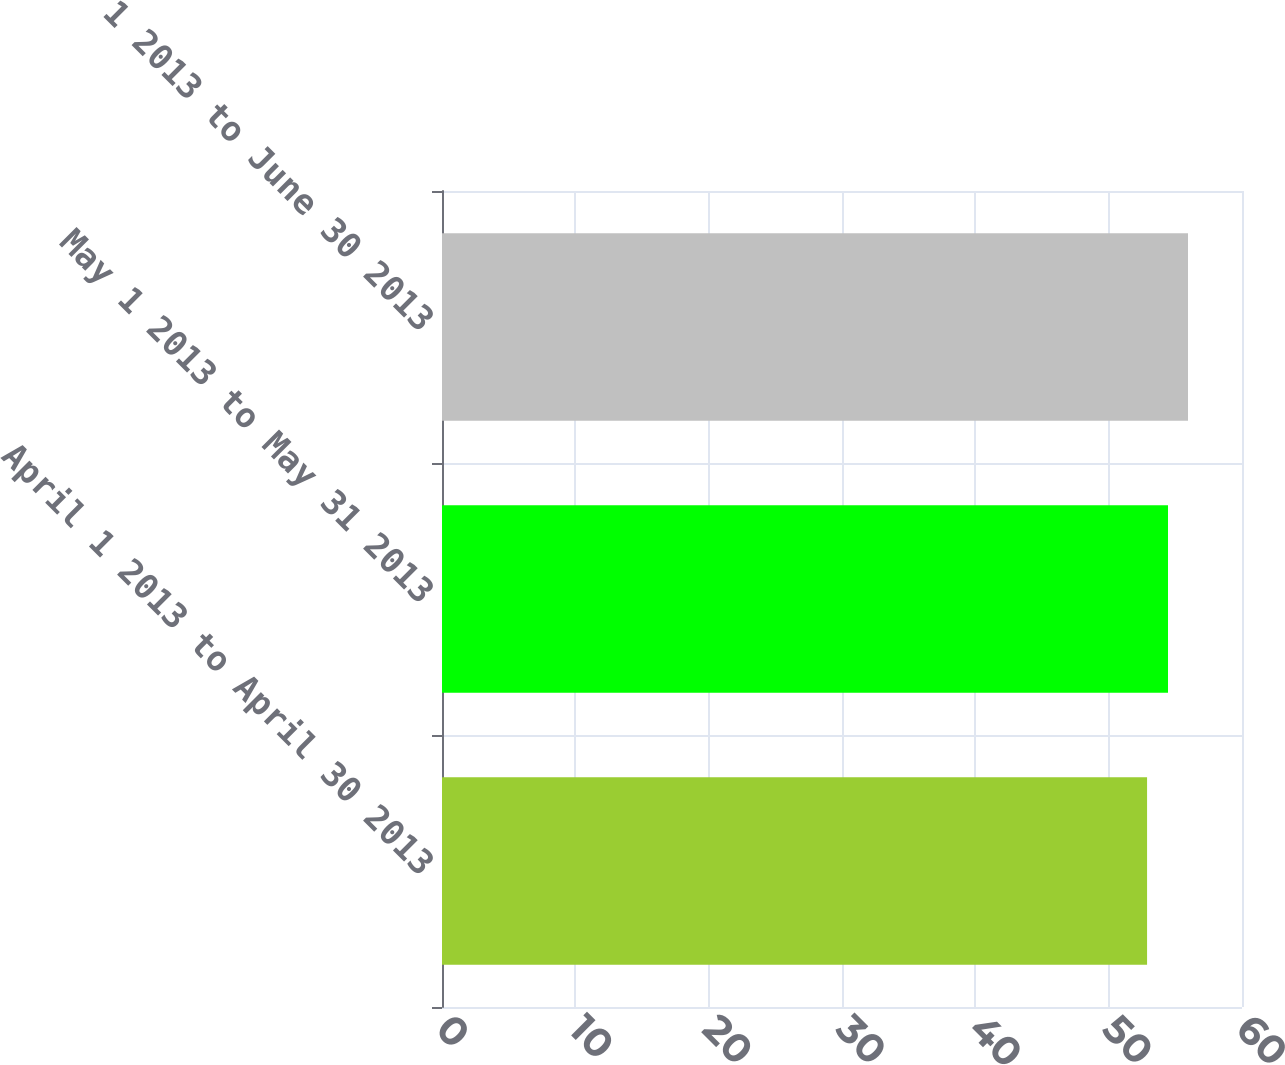Convert chart. <chart><loc_0><loc_0><loc_500><loc_500><bar_chart><fcel>April 1 2013 to April 30 2013<fcel>May 1 2013 to May 31 2013<fcel>June 1 2013 to June 30 2013<nl><fcel>52.88<fcel>54.45<fcel>55.95<nl></chart> 